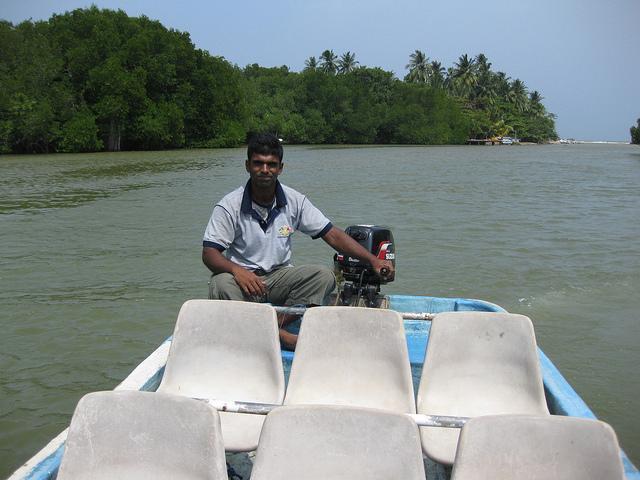How many white seats are shown?
Give a very brief answer. 6. How many chairs can you see?
Give a very brief answer. 5. How many horses are shown?
Give a very brief answer. 0. 